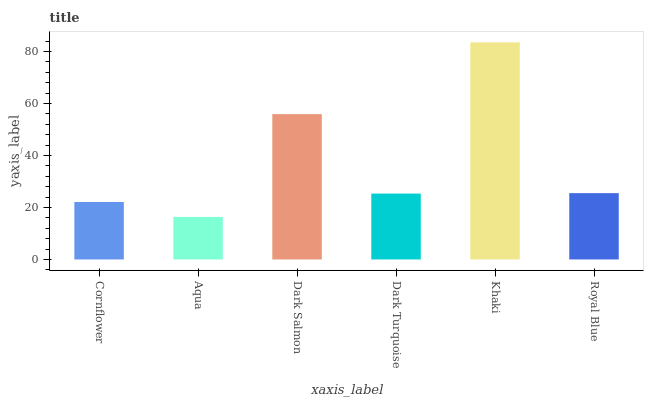Is Aqua the minimum?
Answer yes or no. Yes. Is Khaki the maximum?
Answer yes or no. Yes. Is Dark Salmon the minimum?
Answer yes or no. No. Is Dark Salmon the maximum?
Answer yes or no. No. Is Dark Salmon greater than Aqua?
Answer yes or no. Yes. Is Aqua less than Dark Salmon?
Answer yes or no. Yes. Is Aqua greater than Dark Salmon?
Answer yes or no. No. Is Dark Salmon less than Aqua?
Answer yes or no. No. Is Royal Blue the high median?
Answer yes or no. Yes. Is Dark Turquoise the low median?
Answer yes or no. Yes. Is Dark Turquoise the high median?
Answer yes or no. No. Is Aqua the low median?
Answer yes or no. No. 